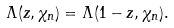<formula> <loc_0><loc_0><loc_500><loc_500>\Lambda ( z , \chi _ { n } ) = \Lambda ( 1 - z , \chi _ { n } ) .</formula> 